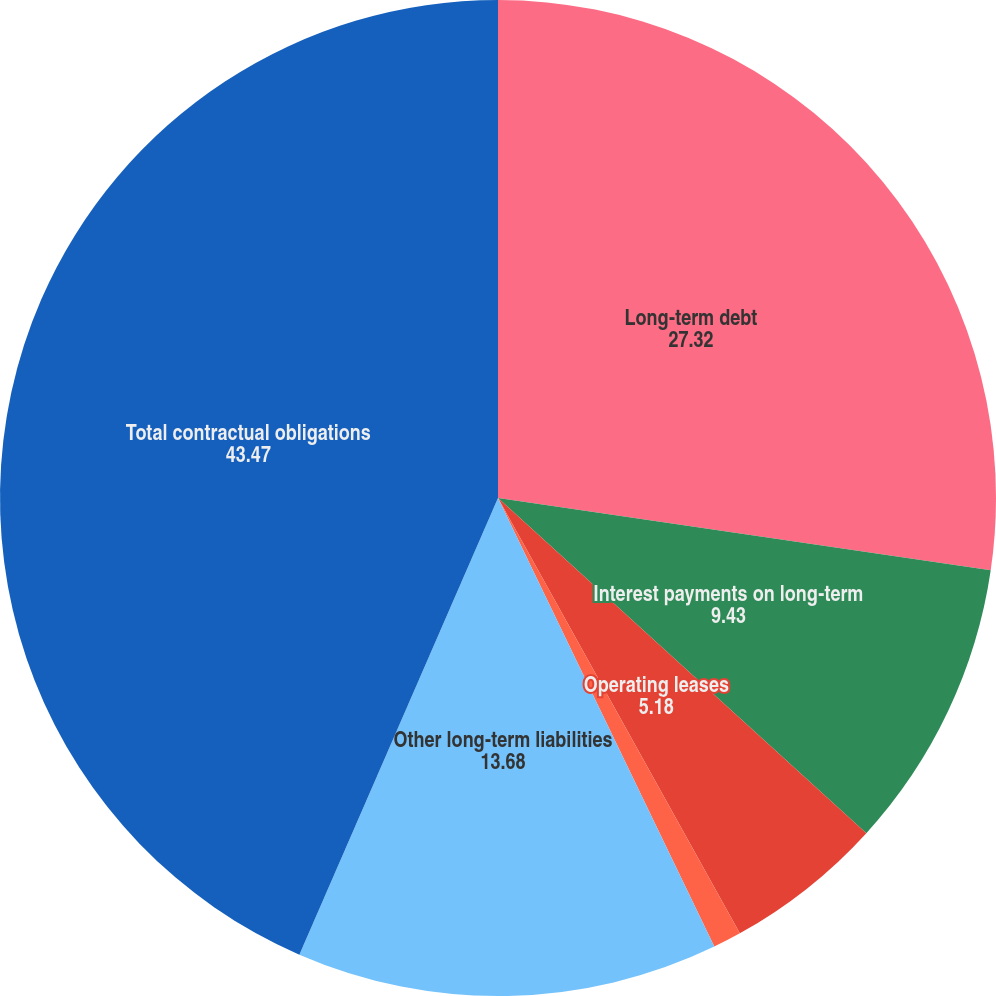Convert chart to OTSL. <chart><loc_0><loc_0><loc_500><loc_500><pie_chart><fcel>Long-term debt<fcel>Interest payments on long-term<fcel>Operating leases<fcel>Purchase obligations (2)<fcel>Other long-term liabilities<fcel>Total contractual obligations<nl><fcel>27.32%<fcel>9.43%<fcel>5.18%<fcel>0.92%<fcel>13.68%<fcel>43.47%<nl></chart> 